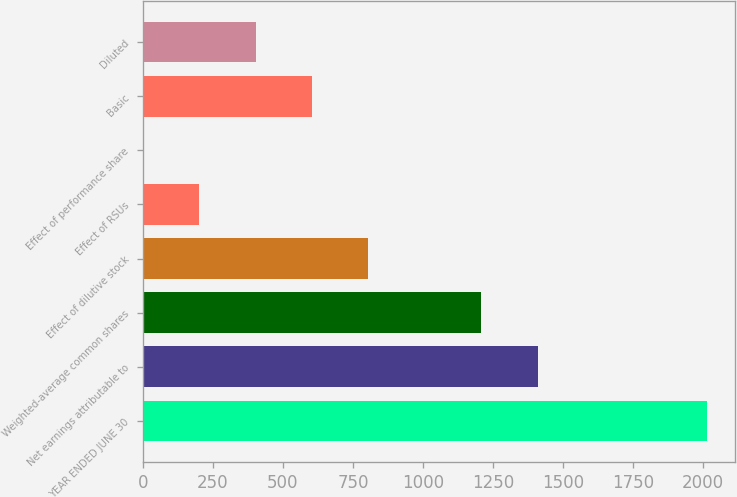Convert chart. <chart><loc_0><loc_0><loc_500><loc_500><bar_chart><fcel>YEAR ENDED JUNE 30<fcel>Net earnings attributable to<fcel>Weighted-average common shares<fcel>Effect of dilutive stock<fcel>Effect of RSUs<fcel>Effect of performance share<fcel>Basic<fcel>Diluted<nl><fcel>2013<fcel>1409.13<fcel>1207.84<fcel>805.26<fcel>201.39<fcel>0.1<fcel>603.97<fcel>402.68<nl></chart> 